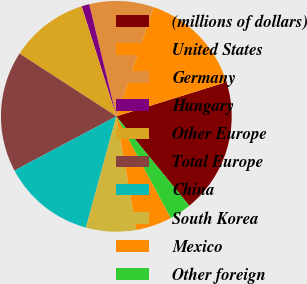<chart> <loc_0><loc_0><loc_500><loc_500><pie_chart><fcel>(millions of dollars)<fcel>United States<fcel>Germany<fcel>Hungary<fcel>Other Europe<fcel>Total Europe<fcel>China<fcel>South Korea<fcel>Mexico<fcel>Other foreign<nl><fcel>18.92%<fcel>14.96%<fcel>9.01%<fcel>1.08%<fcel>10.99%<fcel>16.94%<fcel>12.97%<fcel>7.03%<fcel>5.04%<fcel>3.06%<nl></chart> 